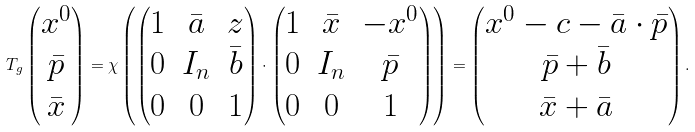Convert formula to latex. <formula><loc_0><loc_0><loc_500><loc_500>T _ { g } \begin{pmatrix} x ^ { 0 } \\ { \bar { p } } \\ { \bar { x } } \end{pmatrix} = \chi \left ( \begin{pmatrix} 1 & { \bar { a } } & z \\ 0 & I _ { n } & { \bar { b } } \\ 0 & 0 & 1 \end{pmatrix} \cdot \begin{pmatrix} 1 & { \bar { x } } & - x ^ { 0 } \\ 0 & I _ { n } & { \bar { p } } \\ 0 & 0 & 1 \end{pmatrix} \right ) = \begin{pmatrix} x ^ { 0 } - c - { \bar { a } } \cdot { \bar { p } } \\ { \bar { p } } + { \bar { b } } \\ { \bar { x } } + { \bar { a } } \end{pmatrix} .</formula> 